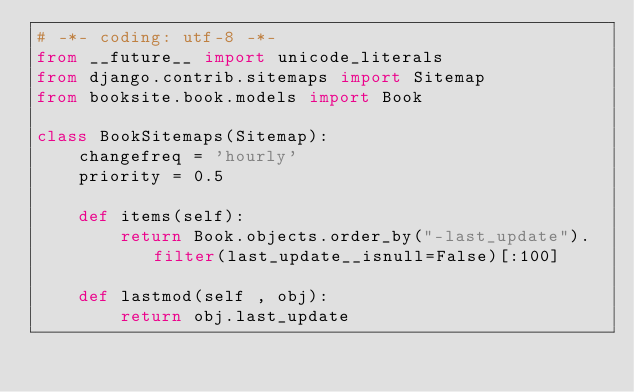Convert code to text. <code><loc_0><loc_0><loc_500><loc_500><_Python_># -*- coding: utf-8 -*-
from __future__ import unicode_literals
from django.contrib.sitemaps import Sitemap
from booksite.book.models import Book

class BookSitemaps(Sitemap):
    changefreq = 'hourly'
    priority = 0.5

    def items(self):
        return Book.objects.order_by("-last_update").filter(last_update__isnull=False)[:100]

    def lastmod(self , obj):
        return obj.last_update
</code> 